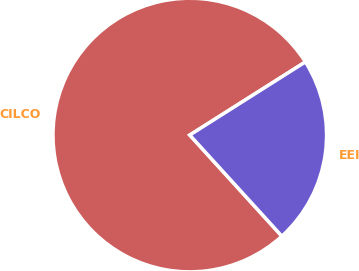Convert chart. <chart><loc_0><loc_0><loc_500><loc_500><pie_chart><fcel>CILCO<fcel>EEI<nl><fcel>77.78%<fcel>22.22%<nl></chart> 